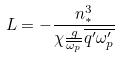<formula> <loc_0><loc_0><loc_500><loc_500>L = - \frac { n _ { * } ^ { 3 } } { \chi \frac { g } { \overline { \omega _ { p } } } \overline { q ^ { \prime } \omega _ { p } ^ { \prime } } }</formula> 